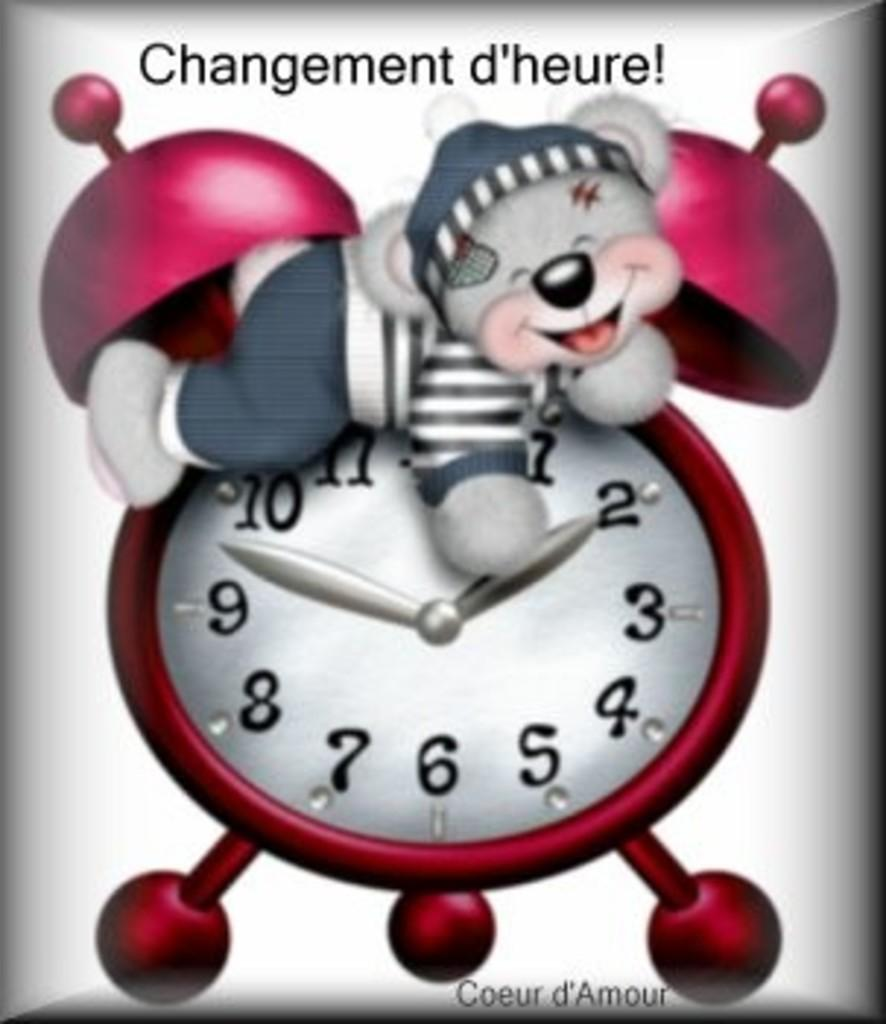<image>
Provide a brief description of the given image. A cartoon  alarm clock picture with a teddy bear on top and a quote, Changement d'heure!ar 